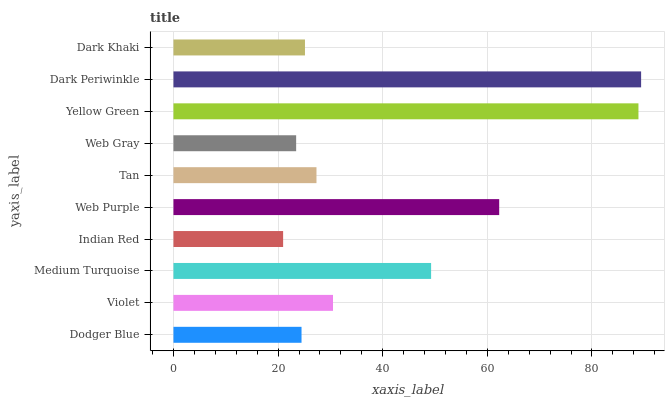Is Indian Red the minimum?
Answer yes or no. Yes. Is Dark Periwinkle the maximum?
Answer yes or no. Yes. Is Violet the minimum?
Answer yes or no. No. Is Violet the maximum?
Answer yes or no. No. Is Violet greater than Dodger Blue?
Answer yes or no. Yes. Is Dodger Blue less than Violet?
Answer yes or no. Yes. Is Dodger Blue greater than Violet?
Answer yes or no. No. Is Violet less than Dodger Blue?
Answer yes or no. No. Is Violet the high median?
Answer yes or no. Yes. Is Tan the low median?
Answer yes or no. Yes. Is Web Gray the high median?
Answer yes or no. No. Is Dark Periwinkle the low median?
Answer yes or no. No. 